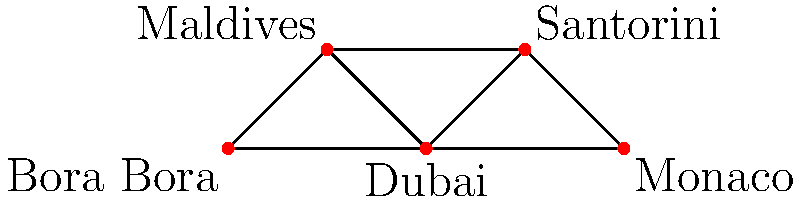In this luxury travel network, each node represents an exclusive destination, and edges represent direct luxury travel routes between them. What is the minimum number of destinations that need to be removed to disconnect Bora Bora from Monaco? To solve this problem, we need to find the minimum cut between Bora Bora and Monaco. Let's approach this step-by-step:

1. Identify the possible paths from Bora Bora to Monaco:
   a. Bora Bora → Dubai → Monaco
   b. Bora Bora → Maldives → Santorini → Monaco
   c. Bora Bora → Dubai → Santorini → Monaco

2. Observe that Dubai appears in two of these paths, making it a critical node.

3. If we remove Dubai, we disconnect all paths from Bora Bora to Monaco:
   - The direct path Bora Bora → Dubai → Monaco is broken.
   - The path Bora Bora → Maldives → Santorini → Monaco remains intact, but it no longer connects to Monaco.
   - The path Bora Bora → Dubai → Santorini → Monaco is also broken.

4. Removing any other single destination would not disconnect Bora Bora from Monaco, as there would always be at least one alternative path.

5. Therefore, Dubai is the minimum cut in this network, and removing it alone is sufficient to disconnect Bora Bora from Monaco.
Answer: 1 